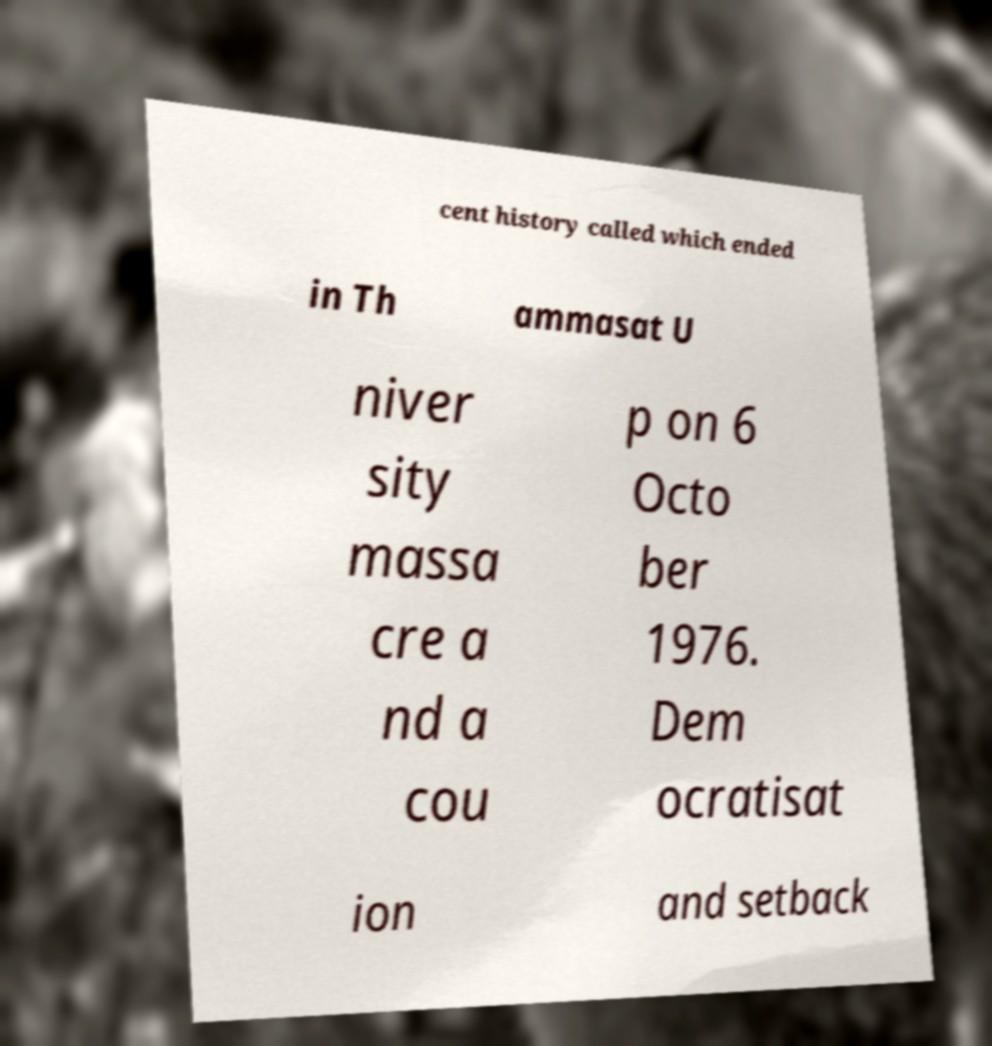There's text embedded in this image that I need extracted. Can you transcribe it verbatim? cent history called which ended in Th ammasat U niver sity massa cre a nd a cou p on 6 Octo ber 1976. Dem ocratisat ion and setback 